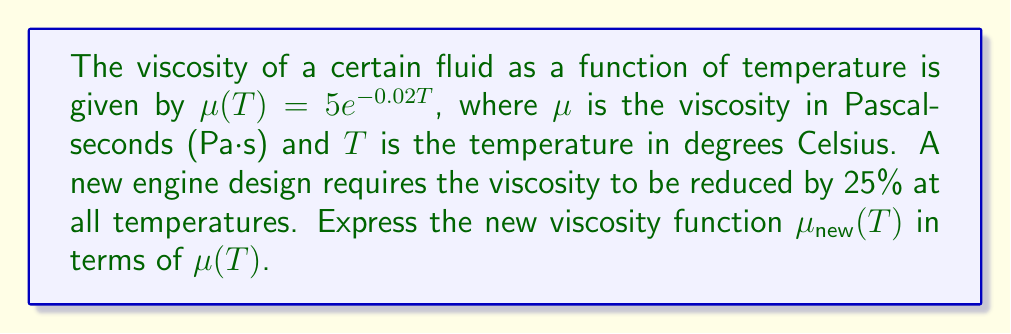Can you answer this question? To solve this problem, we'll use function transformations:

1) The original viscosity function is $\mu(T) = 5e^{-0.02T}$.

2) We need to reduce this function by 25% at all temperatures. This means multiplying the function by 0.75 (since 1 - 0.25 = 0.75).

3) The transformation can be expressed as:

   $\mu_{new}(T) = 0.75 \cdot \mu(T)$

4) Substituting the original function:

   $\mu_{new}(T) = 0.75 \cdot (5e^{-0.02T})$

5) Simplifying:

   $\mu_{new}(T) = 3.75e^{-0.02T}$

6) However, the question asks to express $\mu_{new}(T)$ in terms of $\mu(T)$, not $T$.

7) We can rewrite this as:

   $\mu_{new}(T) = 0.75 \cdot \mu(T)$

This expression directly relates the new viscosity function to the original one, showing that at every temperature, the new viscosity is 75% of the original viscosity.
Answer: $\mu_{new}(T) = 0.75\mu(T)$ 